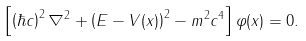Convert formula to latex. <formula><loc_0><loc_0><loc_500><loc_500>\left [ \left ( \hbar { c } \right ) ^ { 2 } \nabla ^ { 2 } + \left ( E - V ( { x } ) \right ) ^ { 2 } - m ^ { 2 } c ^ { 4 } \right ] \varphi ( { x } ) = 0 .</formula> 